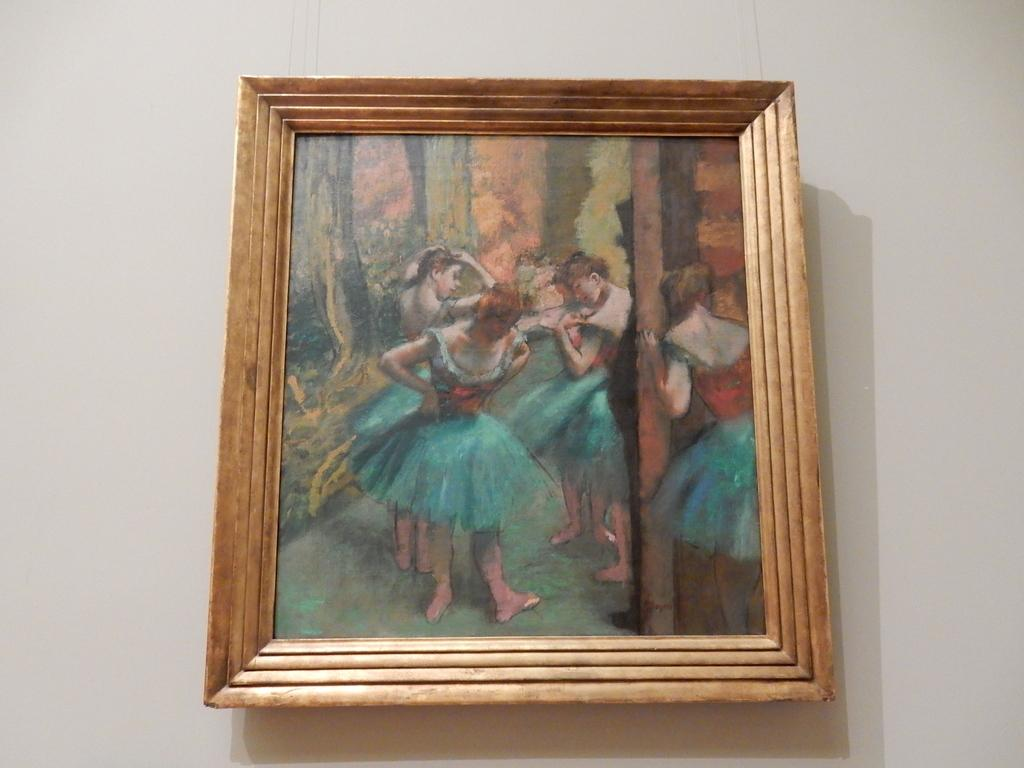What is attached to the wall in the image? There is a frame attached to the wall. What is inside the frame? The frame contains a painting. What is the subject of the painting? The painting depicts a scene with a few women. Reasoning: Let's think step by step by step in order to produce the conversation. We start by identifying the main subject in the image, which is the frame attached to the wall. Then, we expand the conversation to include the contents of the frame, which is a painting. Finally, we describe the subject of the painting, which is a scene with a few women. Each question is designed to elicit a specific detail about the image that is known from the provided facts. Absurd Question/Answer: What type of loss is being experienced by the women in the painting? There is no indication of any loss being experienced by the women in the painting; the painting simply depicts a scene with a few women. What type of root is being depicted in the painting? There is no root depicted in the painting; the painting depicts a scene with a few women. 